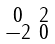Convert formula to latex. <formula><loc_0><loc_0><loc_500><loc_500>\begin{smallmatrix} 0 & 2 \\ - 2 & 0 \end{smallmatrix}</formula> 